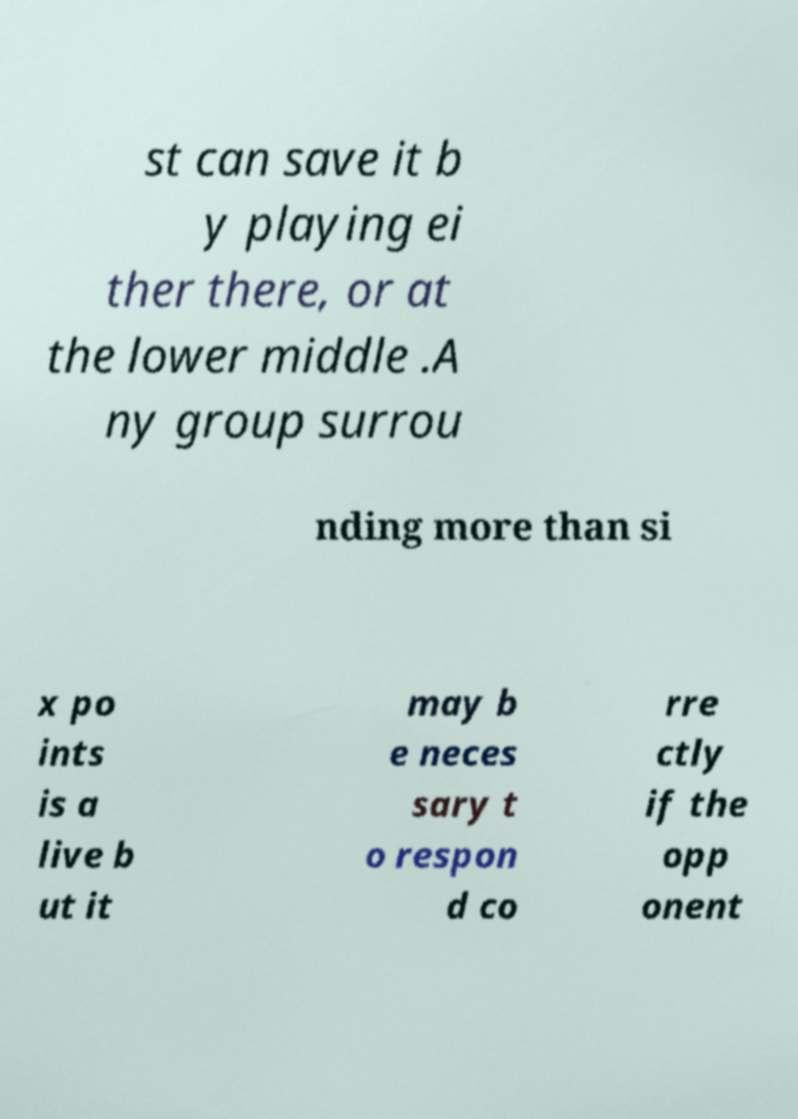For documentation purposes, I need the text within this image transcribed. Could you provide that? st can save it b y playing ei ther there, or at the lower middle .A ny group surrou nding more than si x po ints is a live b ut it may b e neces sary t o respon d co rre ctly if the opp onent 